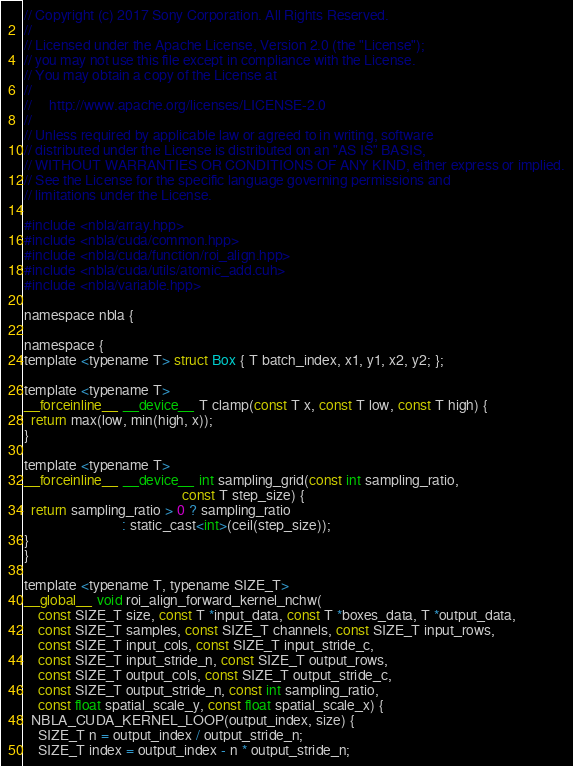<code> <loc_0><loc_0><loc_500><loc_500><_Cuda_>// Copyright (c) 2017 Sony Corporation. All Rights Reserved.
//
// Licensed under the Apache License, Version 2.0 (the "License");
// you may not use this file except in compliance with the License.
// You may obtain a copy of the License at
//
//     http://www.apache.org/licenses/LICENSE-2.0
//
// Unless required by applicable law or agreed to in writing, software
// distributed under the License is distributed on an "AS IS" BASIS,
// WITHOUT WARRANTIES OR CONDITIONS OF ANY KIND, either express or implied.
// See the License for the specific language governing permissions and
// limitations under the License.

#include <nbla/array.hpp>
#include <nbla/cuda/common.hpp>
#include <nbla/cuda/function/roi_align.hpp>
#include <nbla/cuda/utils/atomic_add.cuh>
#include <nbla/variable.hpp>

namespace nbla {

namespace {
template <typename T> struct Box { T batch_index, x1, y1, x2, y2; };

template <typename T>
__forceinline__ __device__ T clamp(const T x, const T low, const T high) {
  return max(low, min(high, x));
}

template <typename T>
__forceinline__ __device__ int sampling_grid(const int sampling_ratio,
                                             const T step_size) {
  return sampling_ratio > 0 ? sampling_ratio
                            : static_cast<int>(ceil(step_size));
}
}

template <typename T, typename SIZE_T>
__global__ void roi_align_forward_kernel_nchw(
    const SIZE_T size, const T *input_data, const T *boxes_data, T *output_data,
    const SIZE_T samples, const SIZE_T channels, const SIZE_T input_rows,
    const SIZE_T input_cols, const SIZE_T input_stride_c,
    const SIZE_T input_stride_n, const SIZE_T output_rows,
    const SIZE_T output_cols, const SIZE_T output_stride_c,
    const SIZE_T output_stride_n, const int sampling_ratio,
    const float spatial_scale_y, const float spatial_scale_x) {
  NBLA_CUDA_KERNEL_LOOP(output_index, size) {
    SIZE_T n = output_index / output_stride_n;
    SIZE_T index = output_index - n * output_stride_n;</code> 